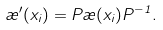Convert formula to latex. <formula><loc_0><loc_0><loc_500><loc_500>\rho ^ { \prime } ( x _ { i } ) = P \rho ( x _ { i } ) P ^ { - 1 } .</formula> 